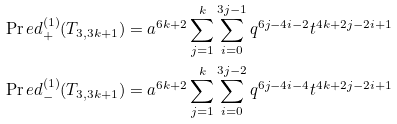<formula> <loc_0><loc_0><loc_500><loc_500>& \Pr e d ^ { ( 1 ) } _ { + } ( T _ { 3 , 3 k + 1 } ) = a ^ { 6 k + 2 } \sum _ { j = 1 } ^ { k } \sum _ { i = 0 } ^ { 3 j - 1 } q ^ { 6 j - 4 i - 2 } t ^ { 4 k + 2 j - 2 i + 1 } \\ & \Pr e d ^ { ( 1 ) } _ { - } ( T _ { 3 , 3 k + 1 } ) = a ^ { 6 k + 2 } \sum _ { j = 1 } ^ { k } \sum _ { i = 0 } ^ { 3 j - 2 } q ^ { 6 j - 4 i - 4 } t ^ { 4 k + 2 j - 2 i + 1 }</formula> 